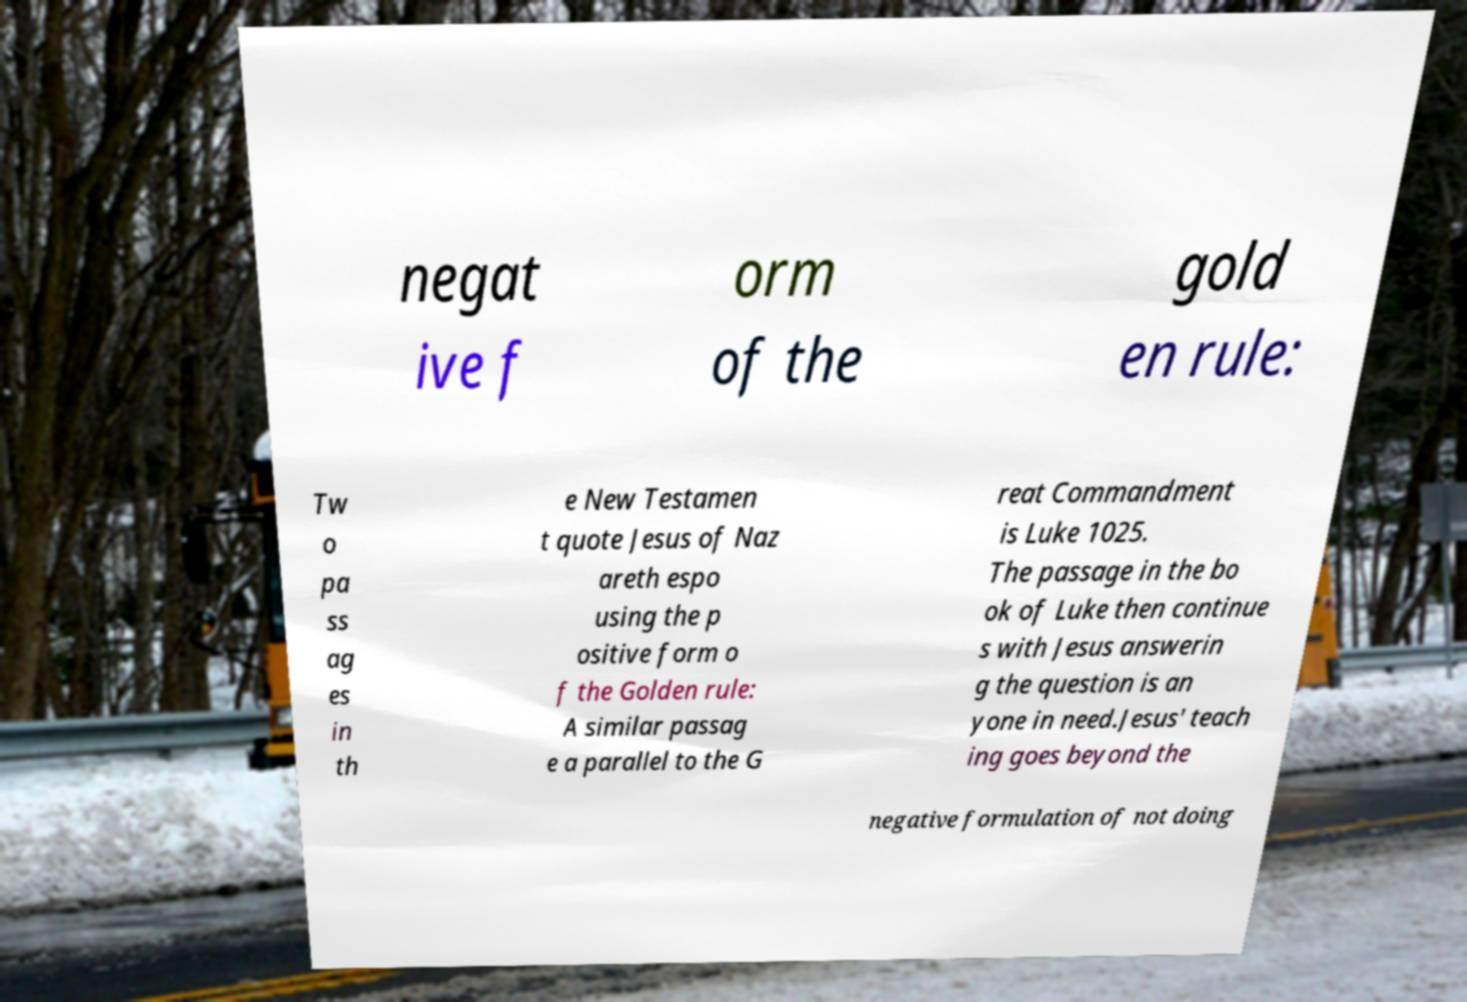I need the written content from this picture converted into text. Can you do that? negat ive f orm of the gold en rule: Tw o pa ss ag es in th e New Testamen t quote Jesus of Naz areth espo using the p ositive form o f the Golden rule: A similar passag e a parallel to the G reat Commandment is Luke 1025. The passage in the bo ok of Luke then continue s with Jesus answerin g the question is an yone in need.Jesus' teach ing goes beyond the negative formulation of not doing 